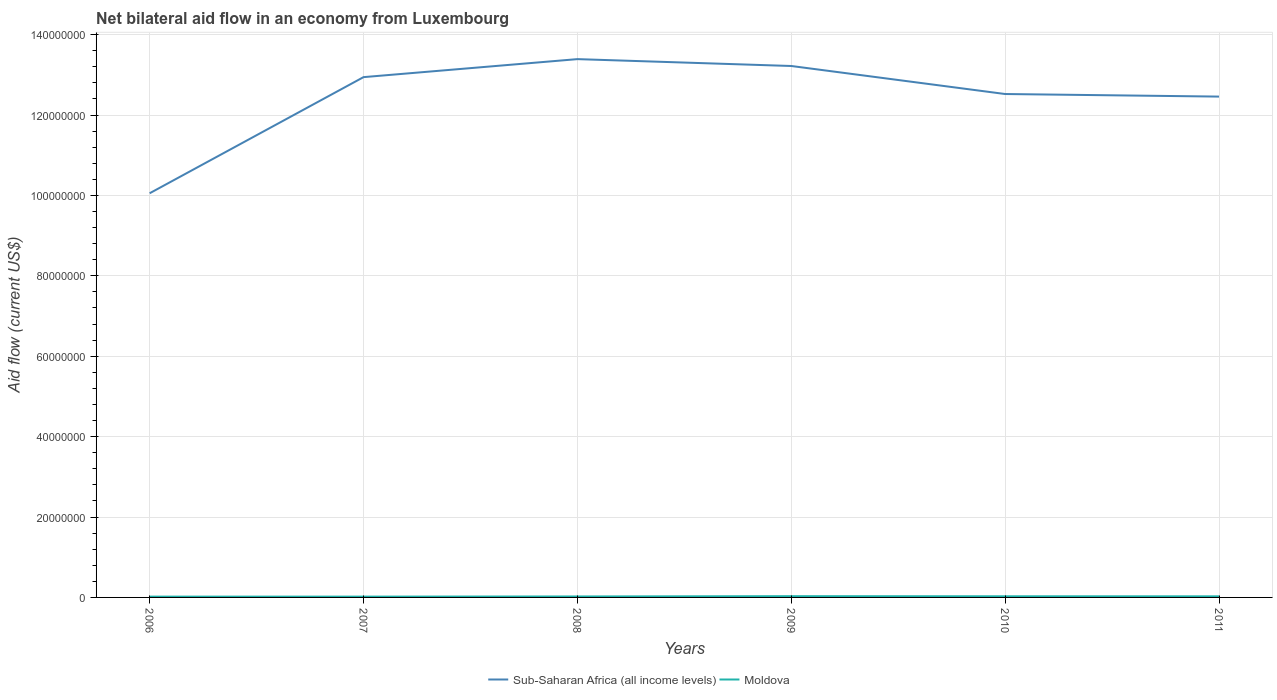Is the number of lines equal to the number of legend labels?
Provide a succinct answer. Yes. What is the total net bilateral aid flow in Moldova in the graph?
Your response must be concise. 4.00e+04. What is the difference between the highest and the second highest net bilateral aid flow in Moldova?
Provide a short and direct response. 1.10e+05. How many years are there in the graph?
Your response must be concise. 6. What is the difference between two consecutive major ticks on the Y-axis?
Offer a very short reply. 2.00e+07. Are the values on the major ticks of Y-axis written in scientific E-notation?
Your answer should be compact. No. What is the title of the graph?
Offer a very short reply. Net bilateral aid flow in an economy from Luxembourg. What is the Aid flow (current US$) of Sub-Saharan Africa (all income levels) in 2006?
Provide a succinct answer. 1.01e+08. What is the Aid flow (current US$) of Moldova in 2006?
Your response must be concise. 2.00e+05. What is the Aid flow (current US$) of Sub-Saharan Africa (all income levels) in 2007?
Keep it short and to the point. 1.29e+08. What is the Aid flow (current US$) in Moldova in 2007?
Ensure brevity in your answer.  2.00e+05. What is the Aid flow (current US$) in Sub-Saharan Africa (all income levels) in 2008?
Give a very brief answer. 1.34e+08. What is the Aid flow (current US$) in Moldova in 2008?
Keep it short and to the point. 2.40e+05. What is the Aid flow (current US$) in Sub-Saharan Africa (all income levels) in 2009?
Your answer should be very brief. 1.32e+08. What is the Aid flow (current US$) in Sub-Saharan Africa (all income levels) in 2010?
Make the answer very short. 1.25e+08. What is the Aid flow (current US$) of Moldova in 2010?
Your response must be concise. 2.80e+05. What is the Aid flow (current US$) in Sub-Saharan Africa (all income levels) in 2011?
Provide a short and direct response. 1.25e+08. What is the Aid flow (current US$) in Moldova in 2011?
Make the answer very short. 2.70e+05. Across all years, what is the maximum Aid flow (current US$) of Sub-Saharan Africa (all income levels)?
Provide a succinct answer. 1.34e+08. Across all years, what is the minimum Aid flow (current US$) in Sub-Saharan Africa (all income levels)?
Provide a short and direct response. 1.01e+08. Across all years, what is the minimum Aid flow (current US$) of Moldova?
Offer a terse response. 2.00e+05. What is the total Aid flow (current US$) in Sub-Saharan Africa (all income levels) in the graph?
Provide a short and direct response. 7.46e+08. What is the total Aid flow (current US$) in Moldova in the graph?
Offer a terse response. 1.50e+06. What is the difference between the Aid flow (current US$) in Sub-Saharan Africa (all income levels) in 2006 and that in 2007?
Provide a short and direct response. -2.89e+07. What is the difference between the Aid flow (current US$) in Moldova in 2006 and that in 2007?
Offer a very short reply. 0. What is the difference between the Aid flow (current US$) of Sub-Saharan Africa (all income levels) in 2006 and that in 2008?
Your answer should be very brief. -3.34e+07. What is the difference between the Aid flow (current US$) of Moldova in 2006 and that in 2008?
Your response must be concise. -4.00e+04. What is the difference between the Aid flow (current US$) of Sub-Saharan Africa (all income levels) in 2006 and that in 2009?
Your answer should be compact. -3.17e+07. What is the difference between the Aid flow (current US$) of Sub-Saharan Africa (all income levels) in 2006 and that in 2010?
Provide a short and direct response. -2.47e+07. What is the difference between the Aid flow (current US$) in Sub-Saharan Africa (all income levels) in 2006 and that in 2011?
Your response must be concise. -2.40e+07. What is the difference between the Aid flow (current US$) in Moldova in 2006 and that in 2011?
Keep it short and to the point. -7.00e+04. What is the difference between the Aid flow (current US$) of Sub-Saharan Africa (all income levels) in 2007 and that in 2008?
Give a very brief answer. -4.48e+06. What is the difference between the Aid flow (current US$) in Sub-Saharan Africa (all income levels) in 2007 and that in 2009?
Your answer should be compact. -2.77e+06. What is the difference between the Aid flow (current US$) of Moldova in 2007 and that in 2009?
Your answer should be very brief. -1.10e+05. What is the difference between the Aid flow (current US$) of Sub-Saharan Africa (all income levels) in 2007 and that in 2010?
Make the answer very short. 4.20e+06. What is the difference between the Aid flow (current US$) in Moldova in 2007 and that in 2010?
Give a very brief answer. -8.00e+04. What is the difference between the Aid flow (current US$) of Sub-Saharan Africa (all income levels) in 2007 and that in 2011?
Keep it short and to the point. 4.84e+06. What is the difference between the Aid flow (current US$) in Sub-Saharan Africa (all income levels) in 2008 and that in 2009?
Give a very brief answer. 1.71e+06. What is the difference between the Aid flow (current US$) of Sub-Saharan Africa (all income levels) in 2008 and that in 2010?
Your answer should be compact. 8.68e+06. What is the difference between the Aid flow (current US$) in Moldova in 2008 and that in 2010?
Ensure brevity in your answer.  -4.00e+04. What is the difference between the Aid flow (current US$) in Sub-Saharan Africa (all income levels) in 2008 and that in 2011?
Provide a succinct answer. 9.32e+06. What is the difference between the Aid flow (current US$) of Moldova in 2008 and that in 2011?
Your answer should be very brief. -3.00e+04. What is the difference between the Aid flow (current US$) of Sub-Saharan Africa (all income levels) in 2009 and that in 2010?
Ensure brevity in your answer.  6.97e+06. What is the difference between the Aid flow (current US$) of Sub-Saharan Africa (all income levels) in 2009 and that in 2011?
Give a very brief answer. 7.61e+06. What is the difference between the Aid flow (current US$) of Sub-Saharan Africa (all income levels) in 2010 and that in 2011?
Give a very brief answer. 6.40e+05. What is the difference between the Aid flow (current US$) in Moldova in 2010 and that in 2011?
Keep it short and to the point. 10000. What is the difference between the Aid flow (current US$) of Sub-Saharan Africa (all income levels) in 2006 and the Aid flow (current US$) of Moldova in 2007?
Offer a terse response. 1.00e+08. What is the difference between the Aid flow (current US$) in Sub-Saharan Africa (all income levels) in 2006 and the Aid flow (current US$) in Moldova in 2008?
Provide a succinct answer. 1.00e+08. What is the difference between the Aid flow (current US$) in Sub-Saharan Africa (all income levels) in 2006 and the Aid flow (current US$) in Moldova in 2009?
Keep it short and to the point. 1.00e+08. What is the difference between the Aid flow (current US$) of Sub-Saharan Africa (all income levels) in 2006 and the Aid flow (current US$) of Moldova in 2010?
Your response must be concise. 1.00e+08. What is the difference between the Aid flow (current US$) of Sub-Saharan Africa (all income levels) in 2006 and the Aid flow (current US$) of Moldova in 2011?
Offer a terse response. 1.00e+08. What is the difference between the Aid flow (current US$) in Sub-Saharan Africa (all income levels) in 2007 and the Aid flow (current US$) in Moldova in 2008?
Give a very brief answer. 1.29e+08. What is the difference between the Aid flow (current US$) in Sub-Saharan Africa (all income levels) in 2007 and the Aid flow (current US$) in Moldova in 2009?
Your answer should be compact. 1.29e+08. What is the difference between the Aid flow (current US$) of Sub-Saharan Africa (all income levels) in 2007 and the Aid flow (current US$) of Moldova in 2010?
Your answer should be compact. 1.29e+08. What is the difference between the Aid flow (current US$) of Sub-Saharan Africa (all income levels) in 2007 and the Aid flow (current US$) of Moldova in 2011?
Your answer should be compact. 1.29e+08. What is the difference between the Aid flow (current US$) of Sub-Saharan Africa (all income levels) in 2008 and the Aid flow (current US$) of Moldova in 2009?
Make the answer very short. 1.34e+08. What is the difference between the Aid flow (current US$) in Sub-Saharan Africa (all income levels) in 2008 and the Aid flow (current US$) in Moldova in 2010?
Your answer should be compact. 1.34e+08. What is the difference between the Aid flow (current US$) of Sub-Saharan Africa (all income levels) in 2008 and the Aid flow (current US$) of Moldova in 2011?
Your answer should be very brief. 1.34e+08. What is the difference between the Aid flow (current US$) in Sub-Saharan Africa (all income levels) in 2009 and the Aid flow (current US$) in Moldova in 2010?
Offer a terse response. 1.32e+08. What is the difference between the Aid flow (current US$) of Sub-Saharan Africa (all income levels) in 2009 and the Aid flow (current US$) of Moldova in 2011?
Offer a terse response. 1.32e+08. What is the difference between the Aid flow (current US$) in Sub-Saharan Africa (all income levels) in 2010 and the Aid flow (current US$) in Moldova in 2011?
Ensure brevity in your answer.  1.25e+08. What is the average Aid flow (current US$) in Sub-Saharan Africa (all income levels) per year?
Your response must be concise. 1.24e+08. In the year 2006, what is the difference between the Aid flow (current US$) in Sub-Saharan Africa (all income levels) and Aid flow (current US$) in Moldova?
Your response must be concise. 1.00e+08. In the year 2007, what is the difference between the Aid flow (current US$) in Sub-Saharan Africa (all income levels) and Aid flow (current US$) in Moldova?
Your response must be concise. 1.29e+08. In the year 2008, what is the difference between the Aid flow (current US$) of Sub-Saharan Africa (all income levels) and Aid flow (current US$) of Moldova?
Keep it short and to the point. 1.34e+08. In the year 2009, what is the difference between the Aid flow (current US$) of Sub-Saharan Africa (all income levels) and Aid flow (current US$) of Moldova?
Your response must be concise. 1.32e+08. In the year 2010, what is the difference between the Aid flow (current US$) in Sub-Saharan Africa (all income levels) and Aid flow (current US$) in Moldova?
Give a very brief answer. 1.25e+08. In the year 2011, what is the difference between the Aid flow (current US$) of Sub-Saharan Africa (all income levels) and Aid flow (current US$) of Moldova?
Provide a short and direct response. 1.24e+08. What is the ratio of the Aid flow (current US$) in Sub-Saharan Africa (all income levels) in 2006 to that in 2007?
Make the answer very short. 0.78. What is the ratio of the Aid flow (current US$) of Sub-Saharan Africa (all income levels) in 2006 to that in 2008?
Keep it short and to the point. 0.75. What is the ratio of the Aid flow (current US$) in Moldova in 2006 to that in 2008?
Provide a short and direct response. 0.83. What is the ratio of the Aid flow (current US$) of Sub-Saharan Africa (all income levels) in 2006 to that in 2009?
Provide a succinct answer. 0.76. What is the ratio of the Aid flow (current US$) of Moldova in 2006 to that in 2009?
Your answer should be compact. 0.65. What is the ratio of the Aid flow (current US$) of Sub-Saharan Africa (all income levels) in 2006 to that in 2010?
Give a very brief answer. 0.8. What is the ratio of the Aid flow (current US$) of Sub-Saharan Africa (all income levels) in 2006 to that in 2011?
Offer a very short reply. 0.81. What is the ratio of the Aid flow (current US$) in Moldova in 2006 to that in 2011?
Your response must be concise. 0.74. What is the ratio of the Aid flow (current US$) of Sub-Saharan Africa (all income levels) in 2007 to that in 2008?
Make the answer very short. 0.97. What is the ratio of the Aid flow (current US$) of Moldova in 2007 to that in 2009?
Your answer should be very brief. 0.65. What is the ratio of the Aid flow (current US$) of Sub-Saharan Africa (all income levels) in 2007 to that in 2010?
Give a very brief answer. 1.03. What is the ratio of the Aid flow (current US$) of Moldova in 2007 to that in 2010?
Keep it short and to the point. 0.71. What is the ratio of the Aid flow (current US$) in Sub-Saharan Africa (all income levels) in 2007 to that in 2011?
Offer a terse response. 1.04. What is the ratio of the Aid flow (current US$) of Moldova in 2007 to that in 2011?
Your answer should be very brief. 0.74. What is the ratio of the Aid flow (current US$) in Sub-Saharan Africa (all income levels) in 2008 to that in 2009?
Your answer should be compact. 1.01. What is the ratio of the Aid flow (current US$) in Moldova in 2008 to that in 2009?
Your answer should be compact. 0.77. What is the ratio of the Aid flow (current US$) in Sub-Saharan Africa (all income levels) in 2008 to that in 2010?
Provide a short and direct response. 1.07. What is the ratio of the Aid flow (current US$) of Sub-Saharan Africa (all income levels) in 2008 to that in 2011?
Make the answer very short. 1.07. What is the ratio of the Aid flow (current US$) in Moldova in 2008 to that in 2011?
Your answer should be very brief. 0.89. What is the ratio of the Aid flow (current US$) of Sub-Saharan Africa (all income levels) in 2009 to that in 2010?
Ensure brevity in your answer.  1.06. What is the ratio of the Aid flow (current US$) in Moldova in 2009 to that in 2010?
Provide a short and direct response. 1.11. What is the ratio of the Aid flow (current US$) in Sub-Saharan Africa (all income levels) in 2009 to that in 2011?
Offer a terse response. 1.06. What is the ratio of the Aid flow (current US$) of Moldova in 2009 to that in 2011?
Ensure brevity in your answer.  1.15. What is the ratio of the Aid flow (current US$) in Sub-Saharan Africa (all income levels) in 2010 to that in 2011?
Your answer should be very brief. 1.01. What is the difference between the highest and the second highest Aid flow (current US$) in Sub-Saharan Africa (all income levels)?
Provide a short and direct response. 1.71e+06. What is the difference between the highest and the lowest Aid flow (current US$) in Sub-Saharan Africa (all income levels)?
Ensure brevity in your answer.  3.34e+07. 